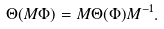Convert formula to latex. <formula><loc_0><loc_0><loc_500><loc_500>\Theta ( M \Phi ) = M \Theta ( \Phi ) M ^ { - 1 } .</formula> 